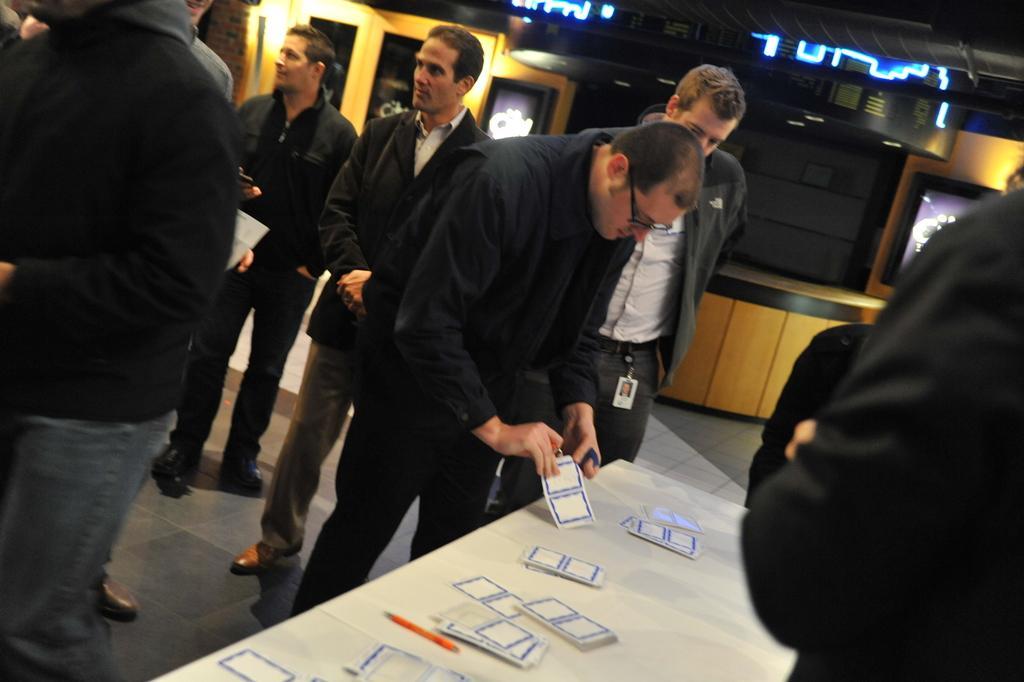Can you describe this image briefly? In the foreground of this image, there are cards and a pen on two tables. On either side to the table, there are people standing on the floor. In the background, there is a circular desk, wall, few lights and the door. 